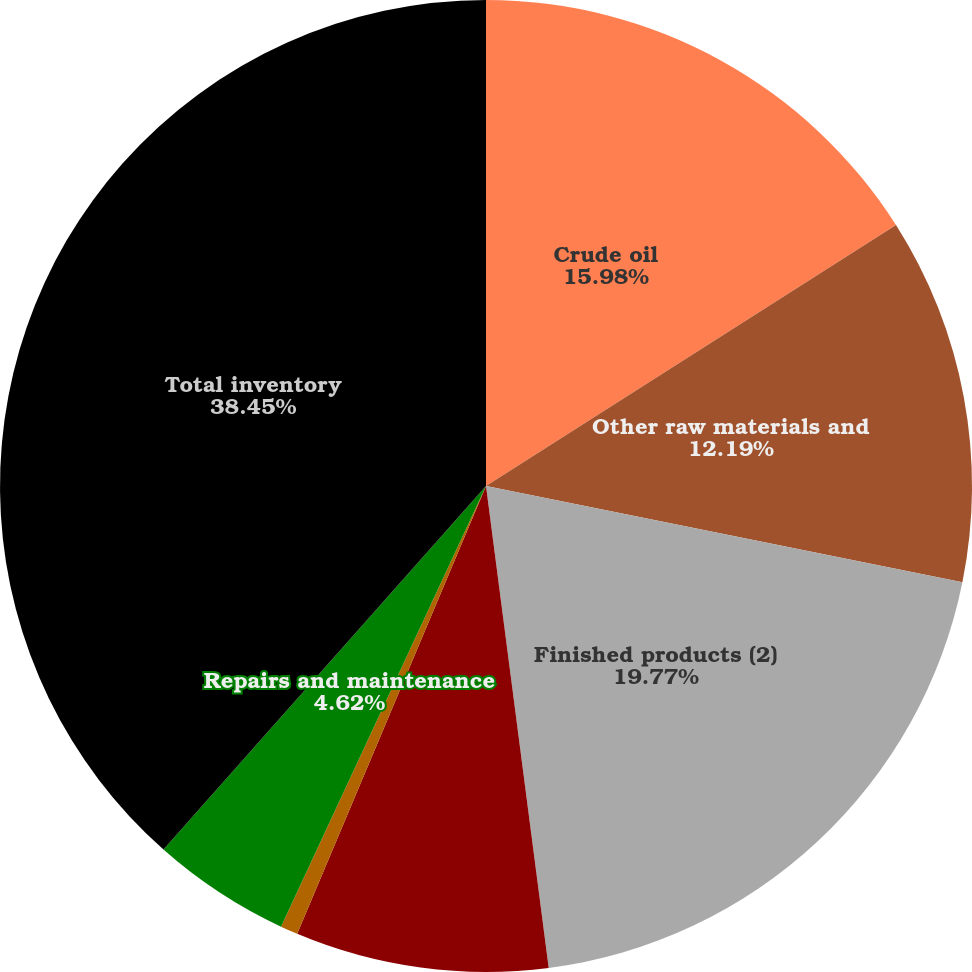Convert chart to OTSL. <chart><loc_0><loc_0><loc_500><loc_500><pie_chart><fcel>Crude oil<fcel>Other raw materials and<fcel>Finished products (2)<fcel>Lower of cost or market<fcel>Process chemicals (3)<fcel>Repairs and maintenance<fcel>Total inventory<nl><fcel>15.98%<fcel>12.19%<fcel>19.77%<fcel>8.41%<fcel>0.58%<fcel>4.62%<fcel>38.45%<nl></chart> 